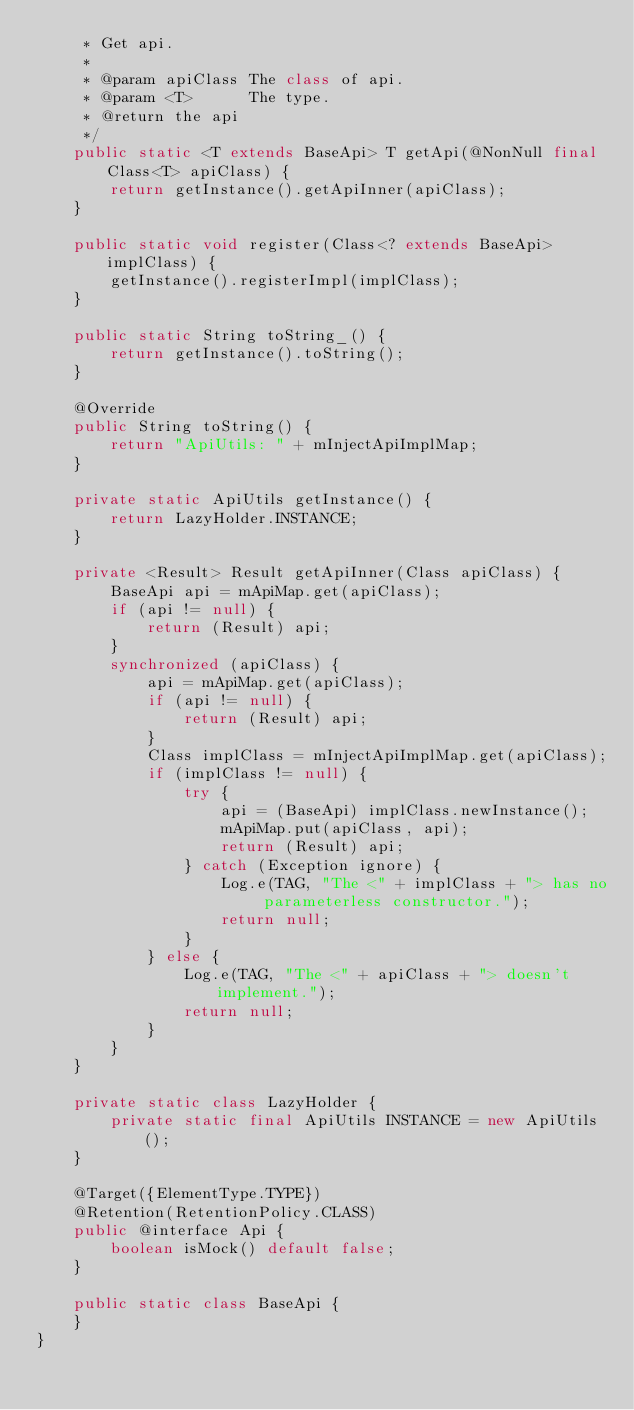<code> <loc_0><loc_0><loc_500><loc_500><_Java_>     * Get api.
     *
     * @param apiClass The class of api.
     * @param <T>      The type.
     * @return the api
     */
    public static <T extends BaseApi> T getApi(@NonNull final Class<T> apiClass) {
        return getInstance().getApiInner(apiClass);
    }

    public static void register(Class<? extends BaseApi> implClass) {
        getInstance().registerImpl(implClass);
    }

    public static String toString_() {
        return getInstance().toString();
    }

    @Override
    public String toString() {
        return "ApiUtils: " + mInjectApiImplMap;
    }

    private static ApiUtils getInstance() {
        return LazyHolder.INSTANCE;
    }

    private <Result> Result getApiInner(Class apiClass) {
        BaseApi api = mApiMap.get(apiClass);
        if (api != null) {
            return (Result) api;
        }
        synchronized (apiClass) {
            api = mApiMap.get(apiClass);
            if (api != null) {
                return (Result) api;
            }
            Class implClass = mInjectApiImplMap.get(apiClass);
            if (implClass != null) {
                try {
                    api = (BaseApi) implClass.newInstance();
                    mApiMap.put(apiClass, api);
                    return (Result) api;
                } catch (Exception ignore) {
                    Log.e(TAG, "The <" + implClass + "> has no parameterless constructor.");
                    return null;
                }
            } else {
                Log.e(TAG, "The <" + apiClass + "> doesn't implement.");
                return null;
            }
        }
    }

    private static class LazyHolder {
        private static final ApiUtils INSTANCE = new ApiUtils();
    }

    @Target({ElementType.TYPE})
    @Retention(RetentionPolicy.CLASS)
    public @interface Api {
        boolean isMock() default false;
    }

    public static class BaseApi {
    }
}</code> 